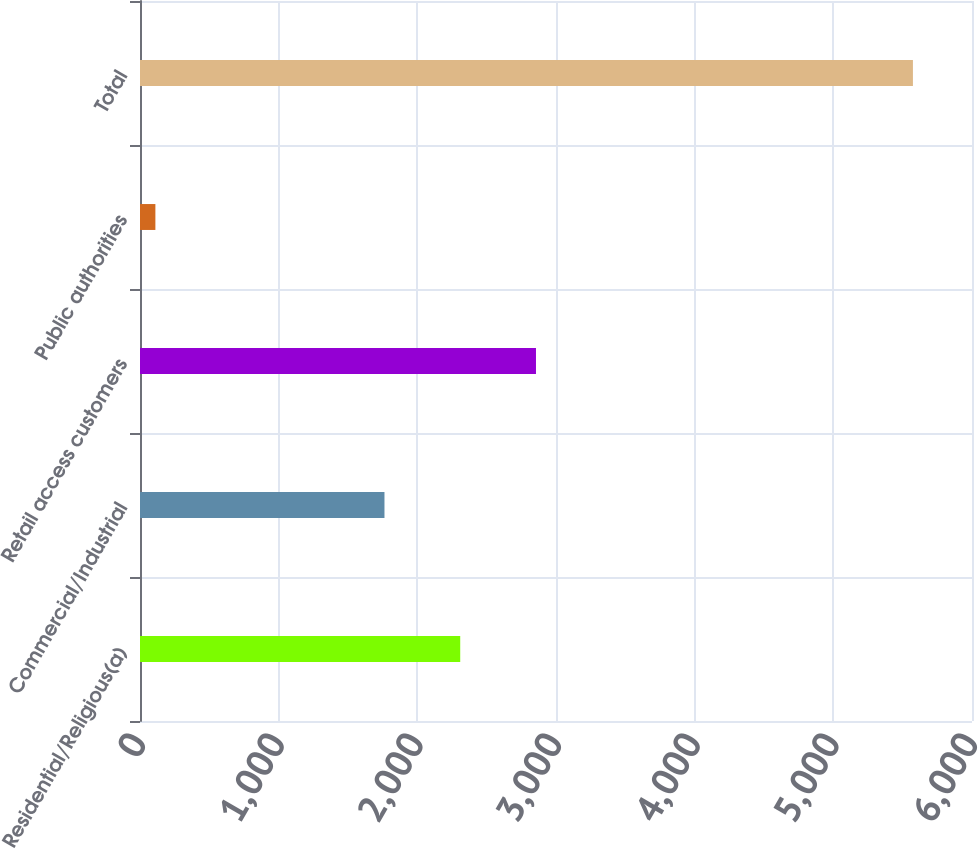Convert chart to OTSL. <chart><loc_0><loc_0><loc_500><loc_500><bar_chart><fcel>Residential/Religious(a)<fcel>Commercial/Industrial<fcel>Retail access customers<fcel>Public authorities<fcel>Total<nl><fcel>2309.3<fcel>1763<fcel>2855.6<fcel>111<fcel>5574<nl></chart> 